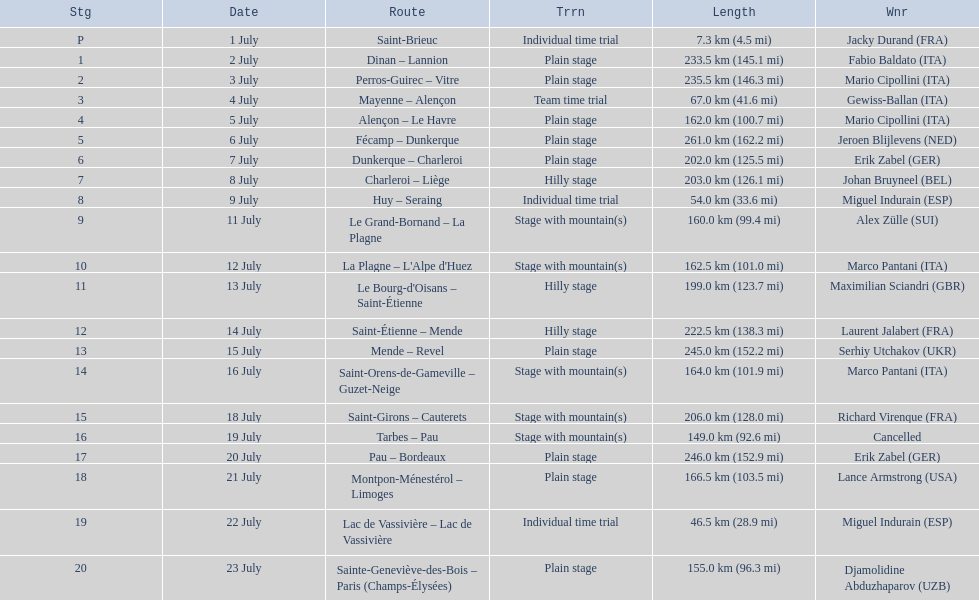What are the dates? 1 July, 2 July, 3 July, 4 July, 5 July, 6 July, 7 July, 8 July, 9 July, 11 July, 12 July, 13 July, 14 July, 15 July, 16 July, 18 July, 19 July, 20 July, 21 July, 22 July, 23 July. What is the length on 8 july? 203.0 km (126.1 mi). 